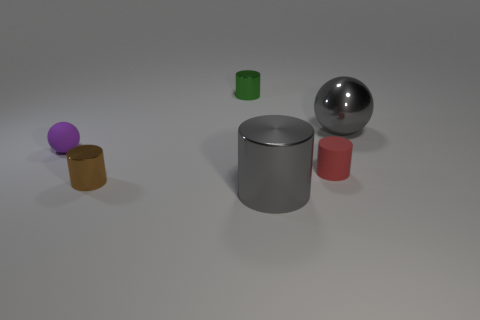Subtract all gray cylinders. How many cylinders are left? 3 Subtract all purple cylinders. Subtract all cyan spheres. How many cylinders are left? 4 Add 3 tiny rubber cylinders. How many objects exist? 9 Subtract all spheres. How many objects are left? 4 Add 5 green matte things. How many green matte things exist? 5 Subtract 0 green spheres. How many objects are left? 6 Subtract all cubes. Subtract all gray metallic cylinders. How many objects are left? 5 Add 4 small purple objects. How many small purple objects are left? 5 